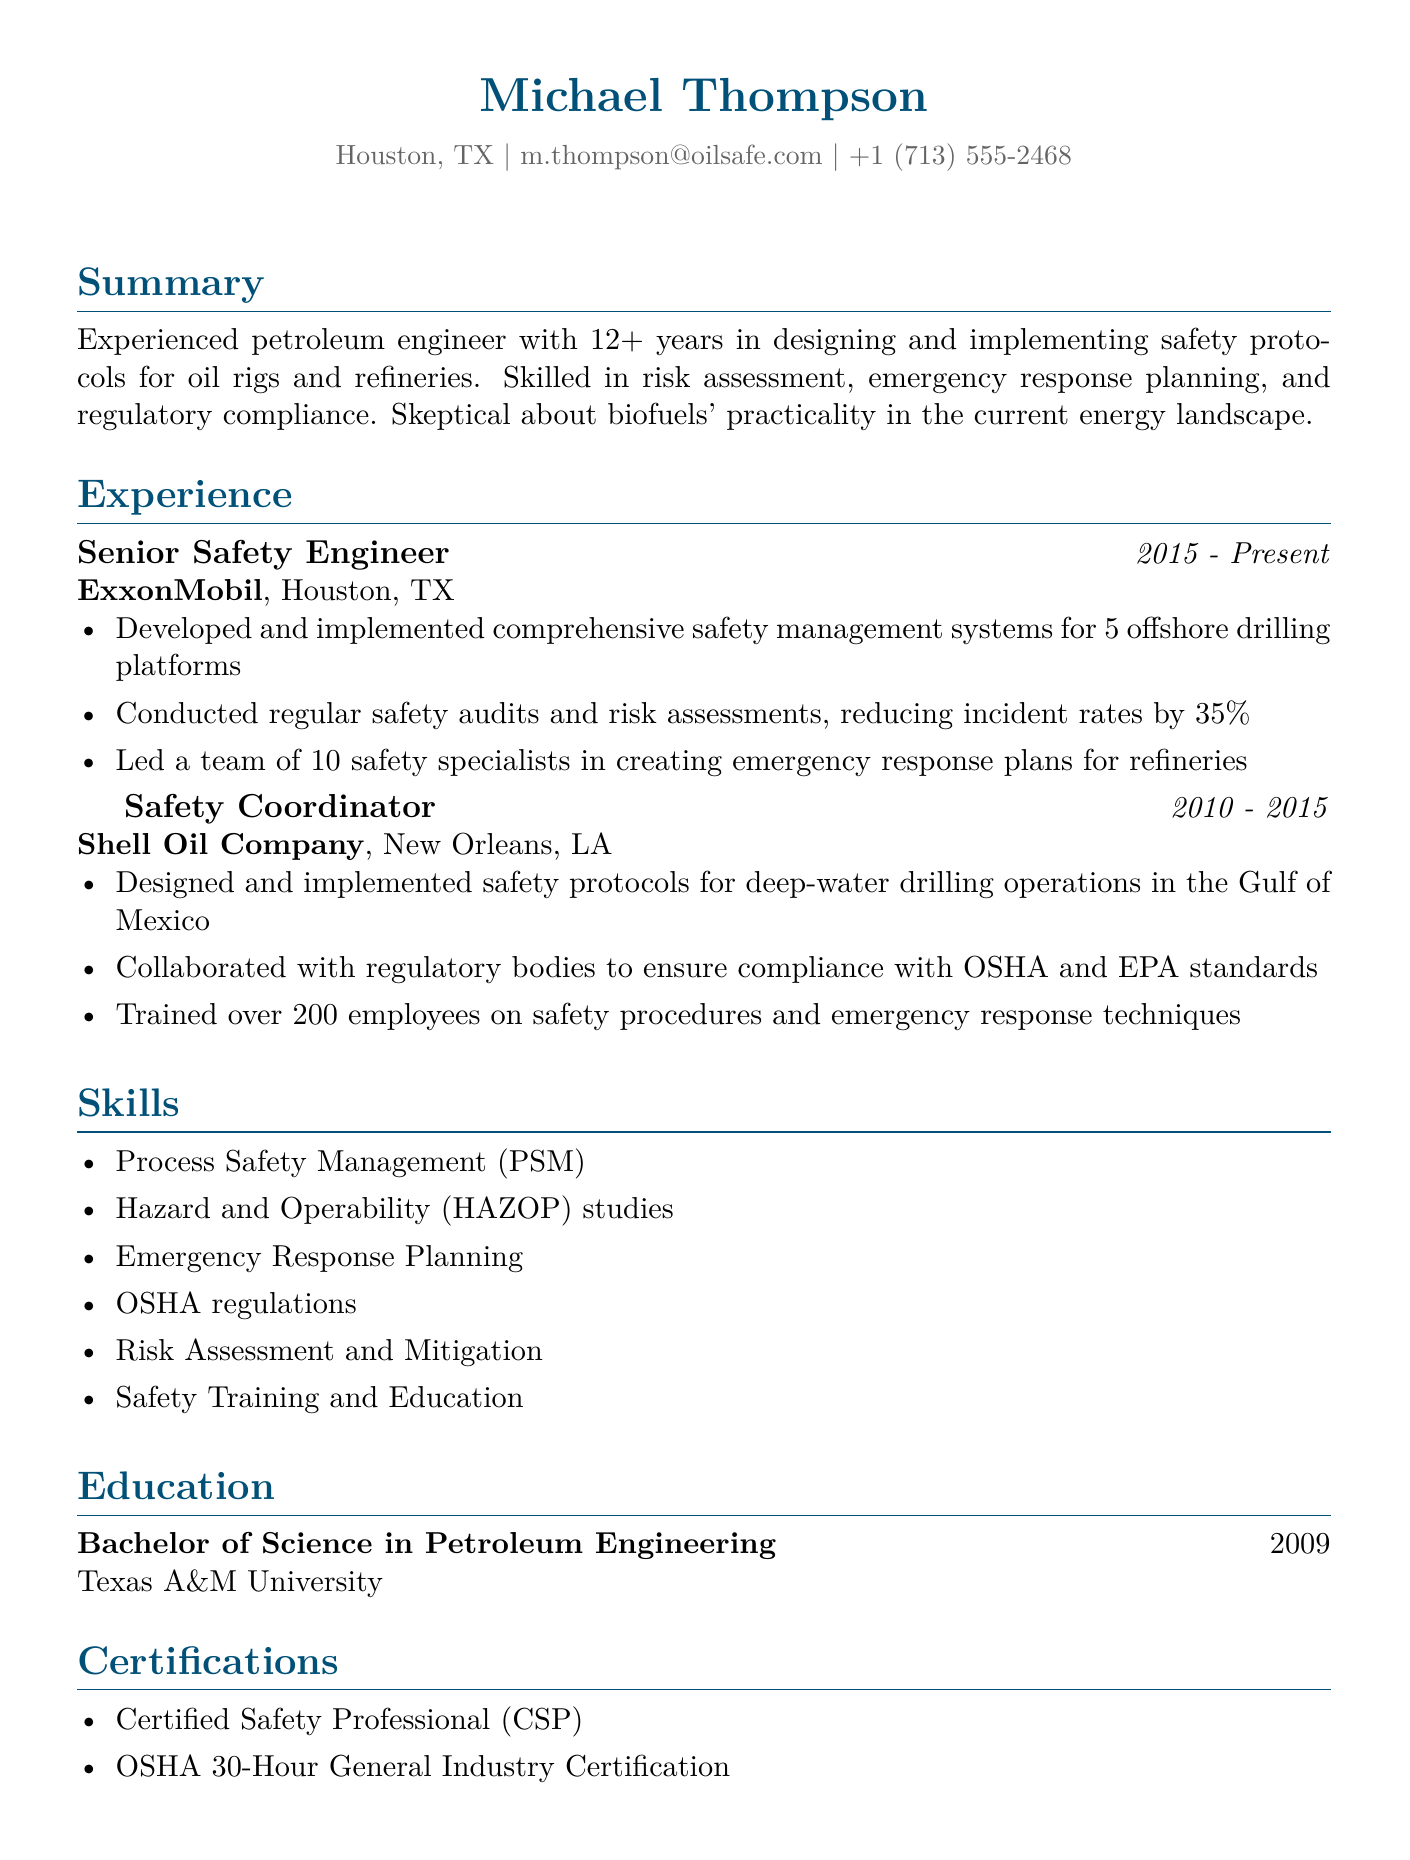What is the name of the candidate? The candidate's name is listed at the top of the document.
Answer: Michael Thompson What is the email address provided in the resume? The email address is mentioned in the personal information section of the document.
Answer: m.thompson@oilsafe.com How many years of experience does the candidate have? The candidate states their total years of experience in the summary section.
Answer: 12+ What position does the candidate currently hold? The current position is listed in the experience section as the most recent role.
Answer: Senior Safety Engineer What company did the candidate work for between 2010 and 2015? The previous employment is detailed in the experience section, specifically the title and company name.
Answer: Shell Oil Company How many safety specialists led by the candidate in their current role? The number of specialists is mentioned in the responsibilities of the current position.
Answer: 10 What degree did the candidate obtain? The candidate's educational qualification is mentioned towards the end of the document.
Answer: Bachelor of Science in Petroleum Engineering What certification does the candidate have that demonstrates safety expertise? The certifications section lists the professional qualification relevant to safety.
Answer: Certified Safety Professional (CSP) How much did the candidate reduce incident rates by in their current job? The improvement statistic is presented in the responsibilities of the current position.
Answer: 35% 